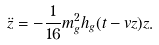Convert formula to latex. <formula><loc_0><loc_0><loc_500><loc_500>\ddot { z } = - \frac { 1 } { 1 6 } m _ { g } ^ { 2 } h _ { g } ( t - v z ) z .</formula> 